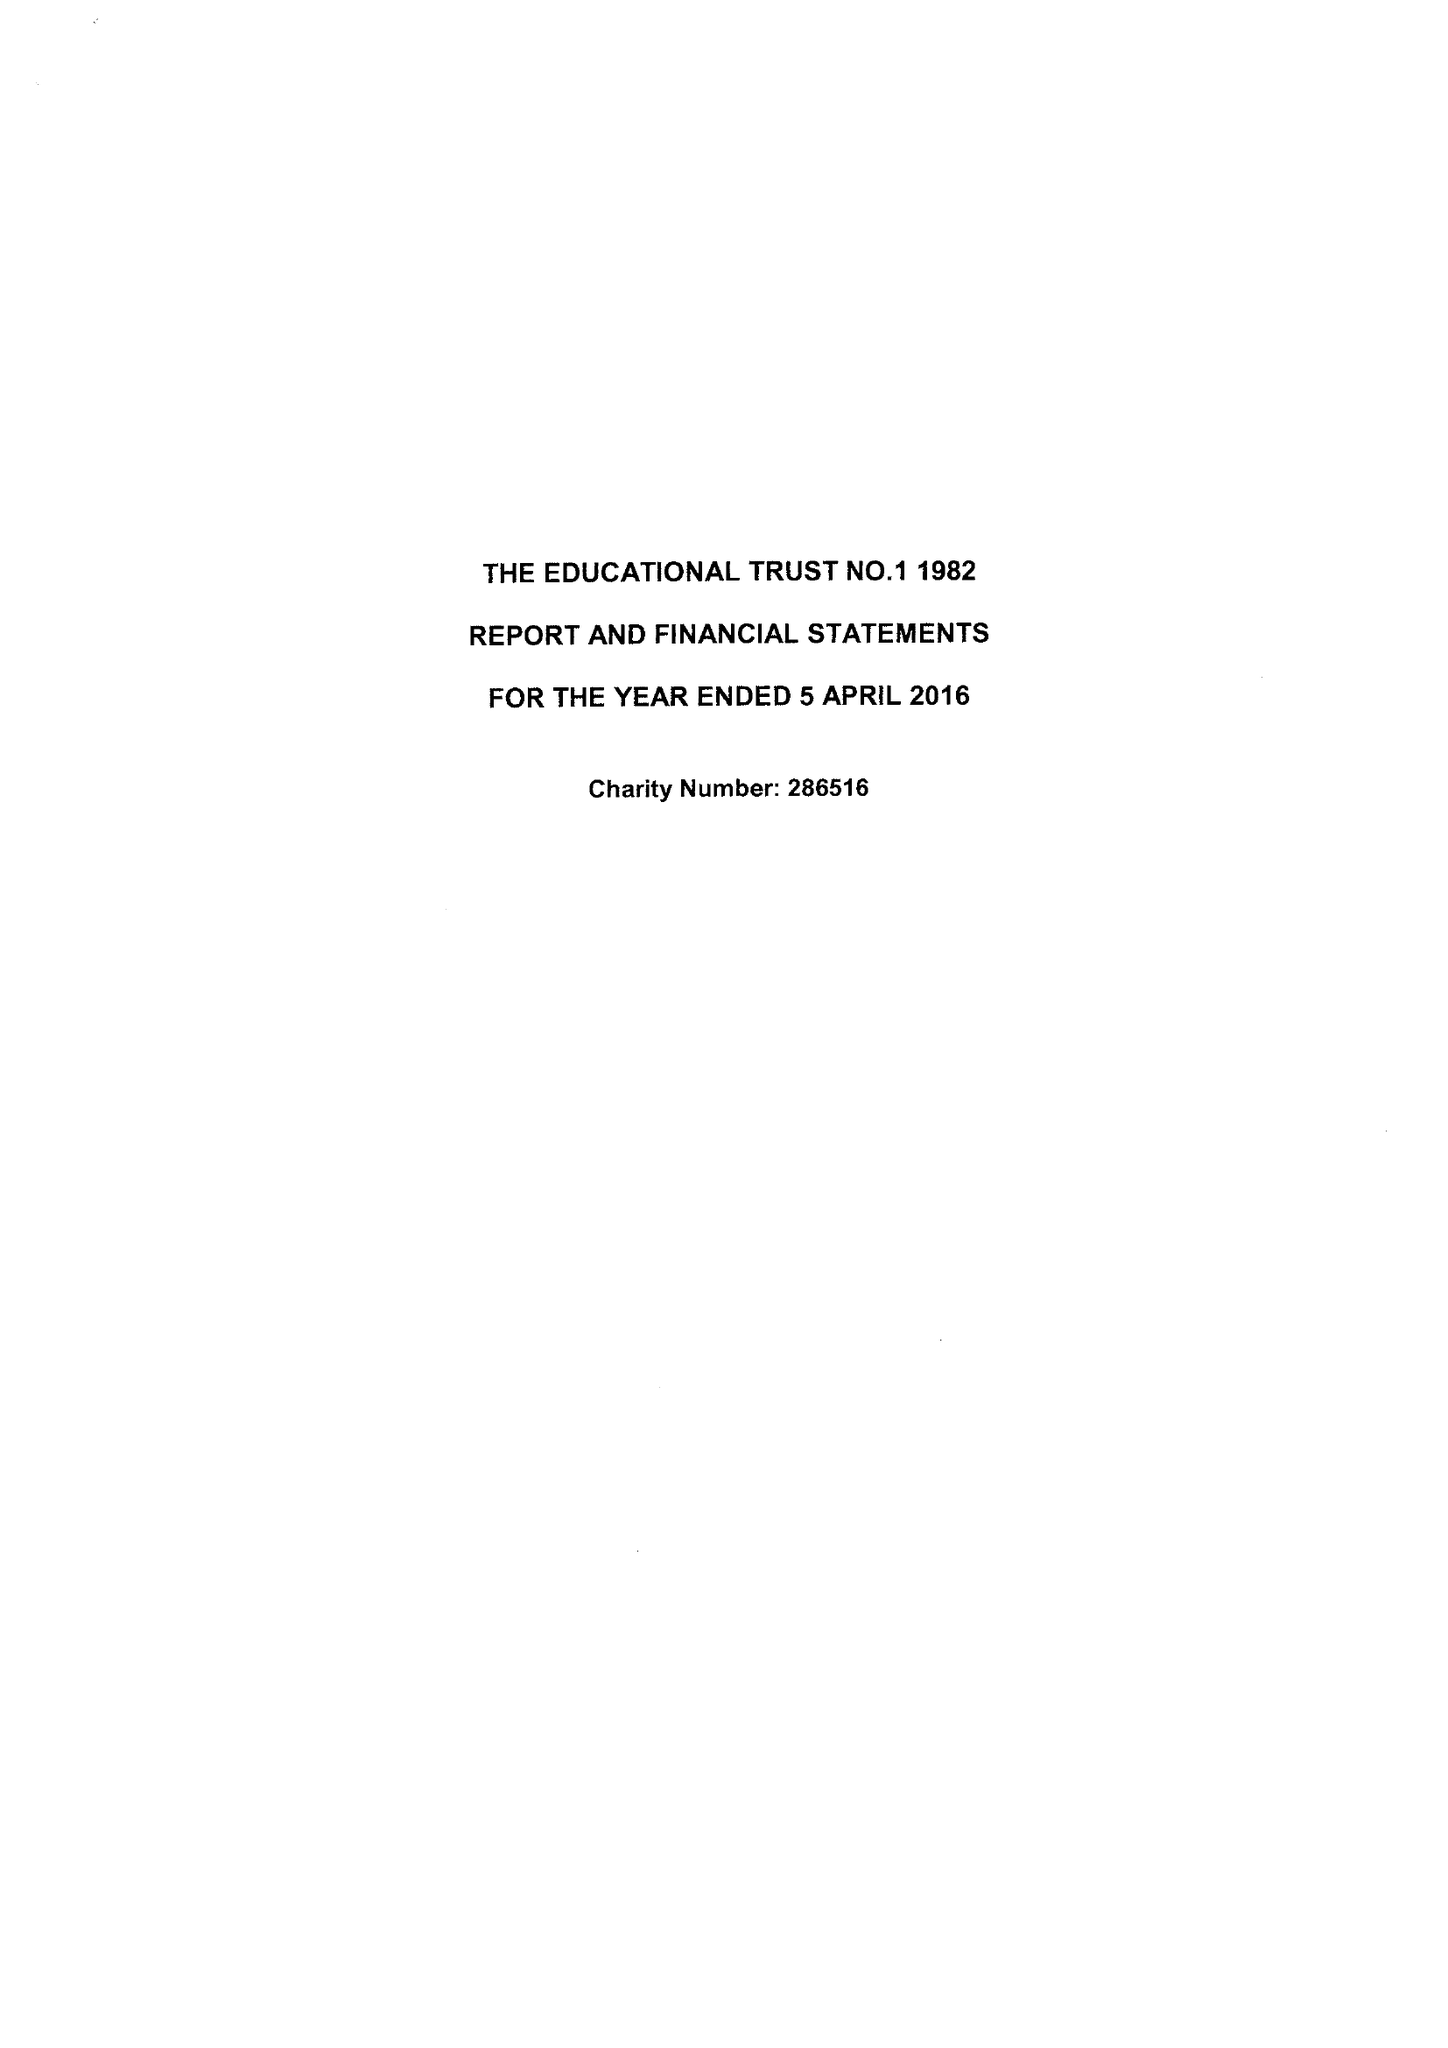What is the value for the address__postcode?
Answer the question using a single word or phrase. PO15 7PA 